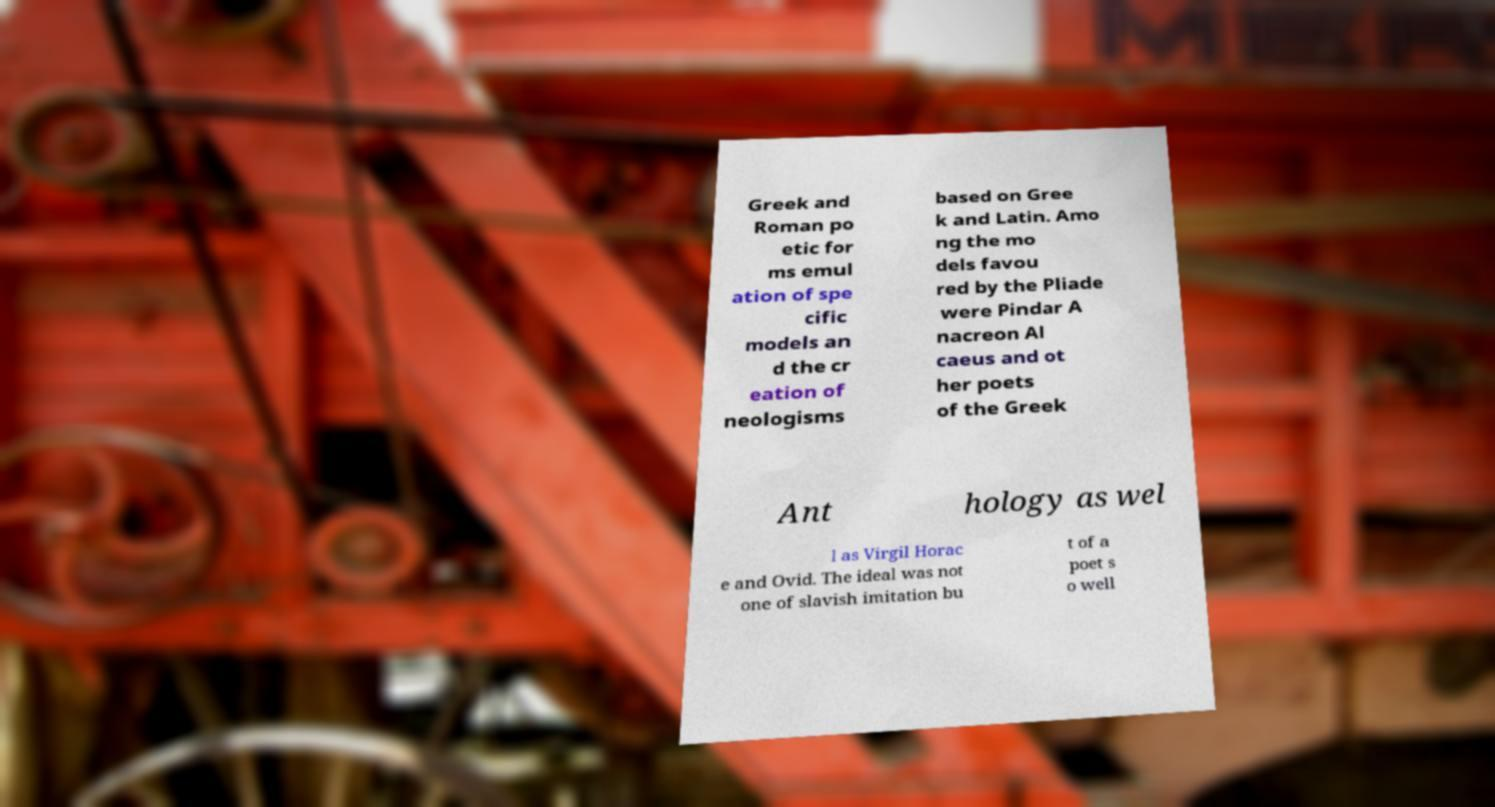For documentation purposes, I need the text within this image transcribed. Could you provide that? Greek and Roman po etic for ms emul ation of spe cific models an d the cr eation of neologisms based on Gree k and Latin. Amo ng the mo dels favou red by the Pliade were Pindar A nacreon Al caeus and ot her poets of the Greek Ant hology as wel l as Virgil Horac e and Ovid. The ideal was not one of slavish imitation bu t of a poet s o well 